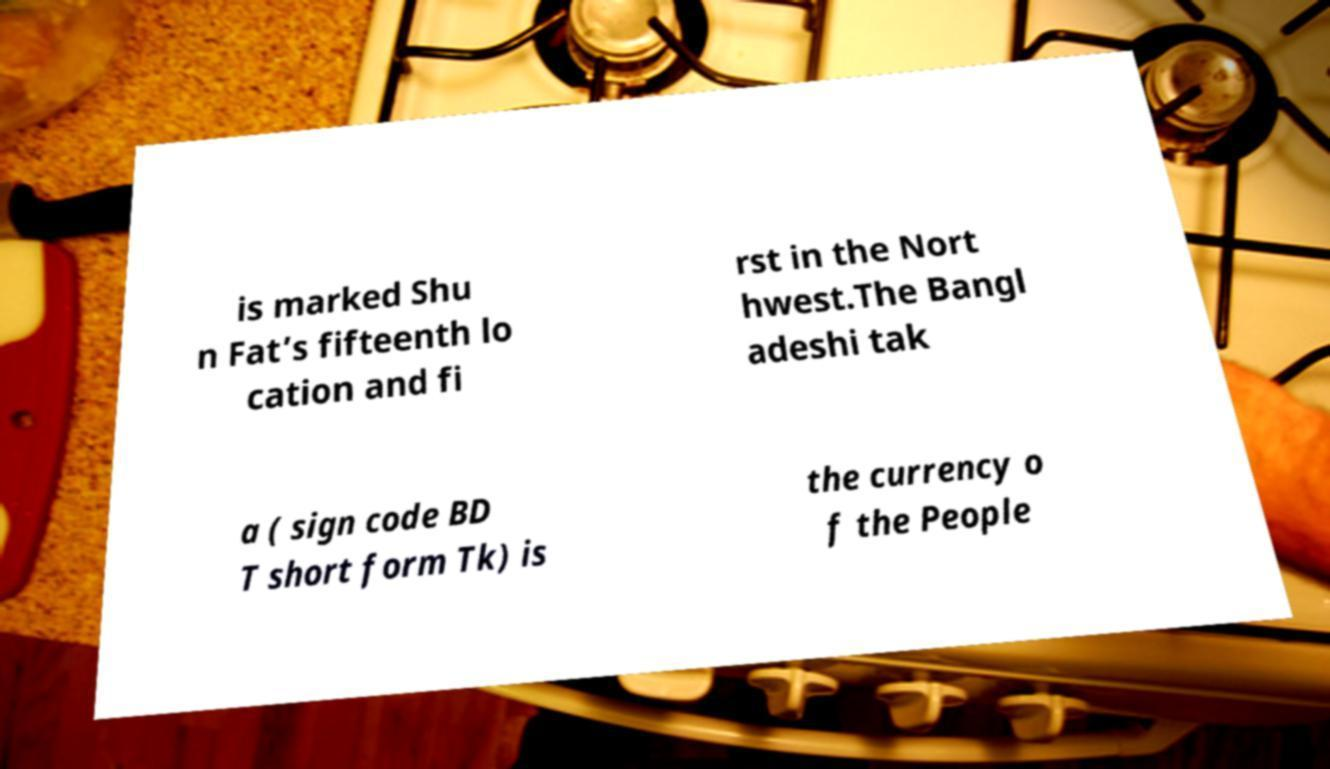I need the written content from this picture converted into text. Can you do that? is marked Shu n Fat’s fifteenth lo cation and fi rst in the Nort hwest.The Bangl adeshi tak a ( sign code BD T short form Tk) is the currency o f the People 